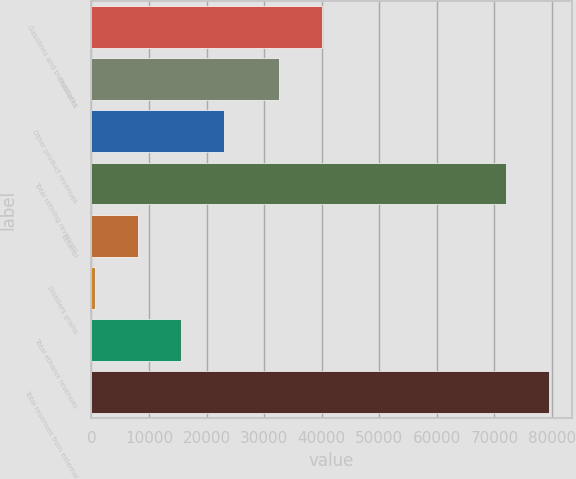<chart> <loc_0><loc_0><loc_500><loc_500><bar_chart><fcel>Gasolines and blendstocks<fcel>Distillates<fcel>Other product revenues<fcel>Total refining revenues<fcel>Ethanol<fcel>Distillers grains<fcel>Total ethanol revenues<fcel>Total revenues from external<nl><fcel>40083.3<fcel>32576<fcel>23107.9<fcel>71968<fcel>8093.3<fcel>586<fcel>15600.6<fcel>79475.3<nl></chart> 